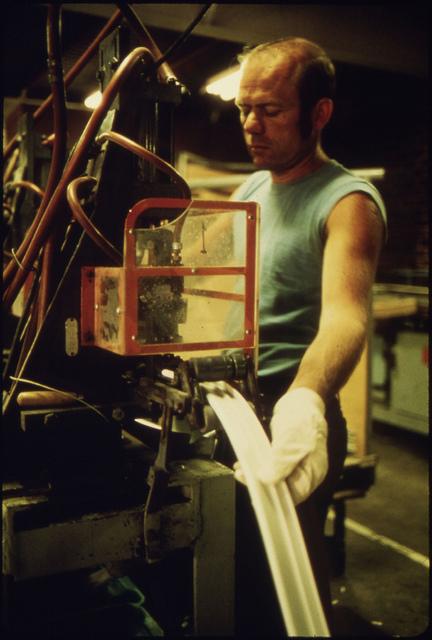Is he doing a trick?
Write a very short answer. No. Is the man cooking?
Short answer required. No. Why does he wear gloves?
Answer briefly. Safety. What event is happening?
Concise answer only. Manufacturing. What color is his shirt?
Be succinct. Gray. 